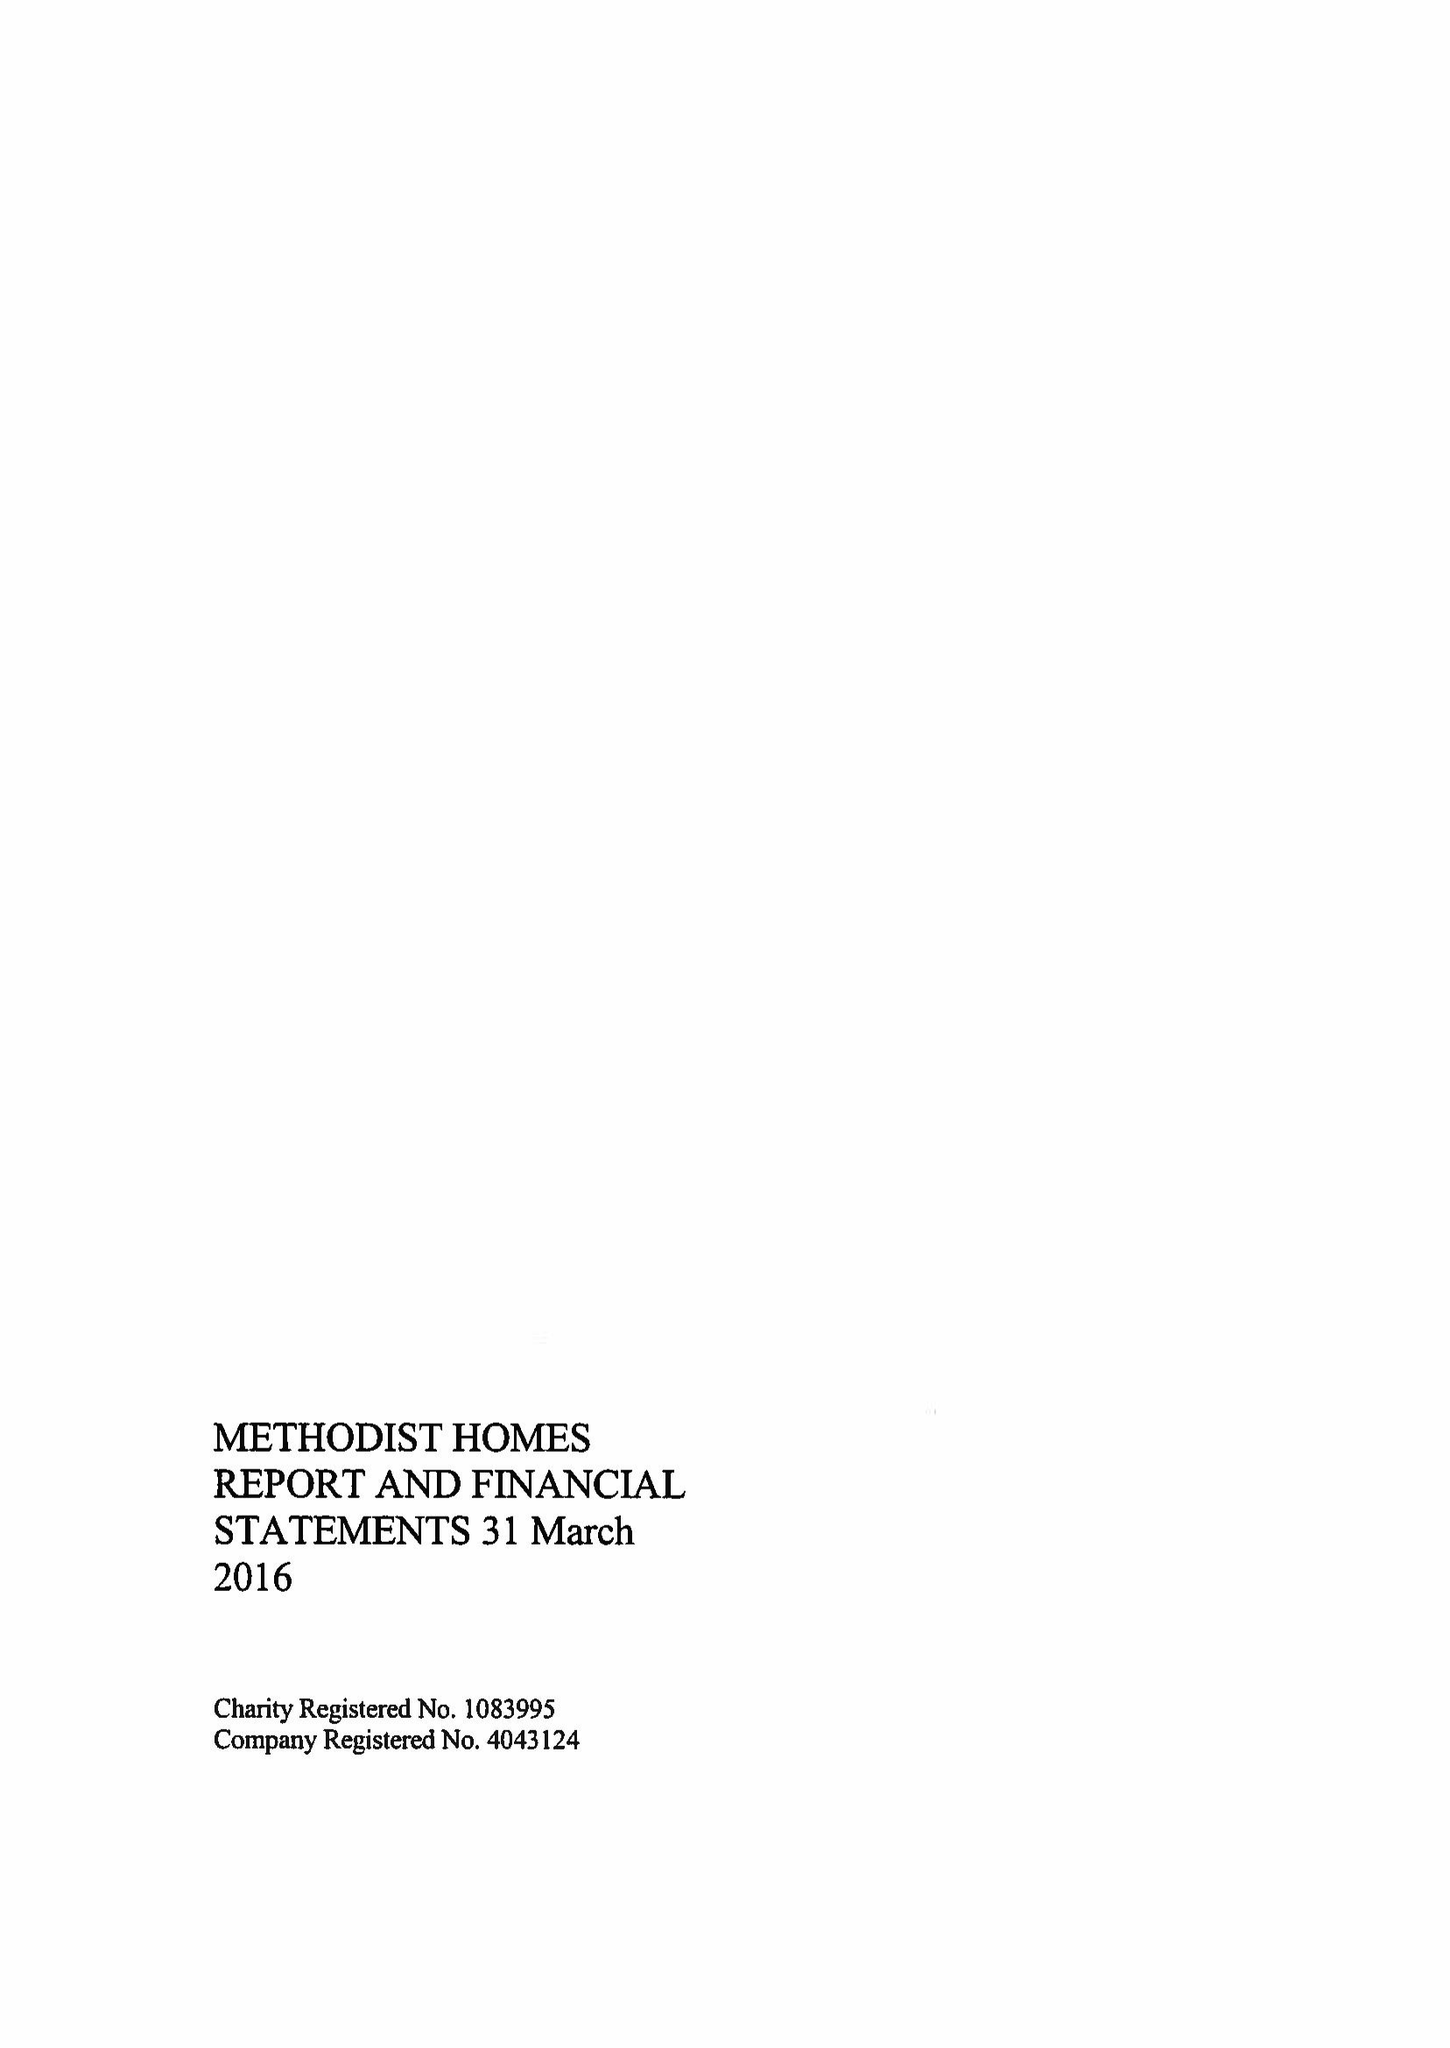What is the value for the address__post_town?
Answer the question using a single word or phrase. DERBY 